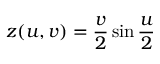Convert formula to latex. <formula><loc_0><loc_0><loc_500><loc_500>z ( u , v ) = { \frac { v } { 2 } } \sin { \frac { u } { 2 } }</formula> 